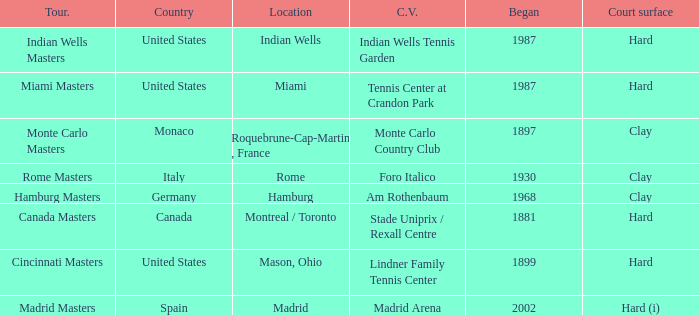How many competitions use the lindner family tennis center as their existing location? 1.0. 